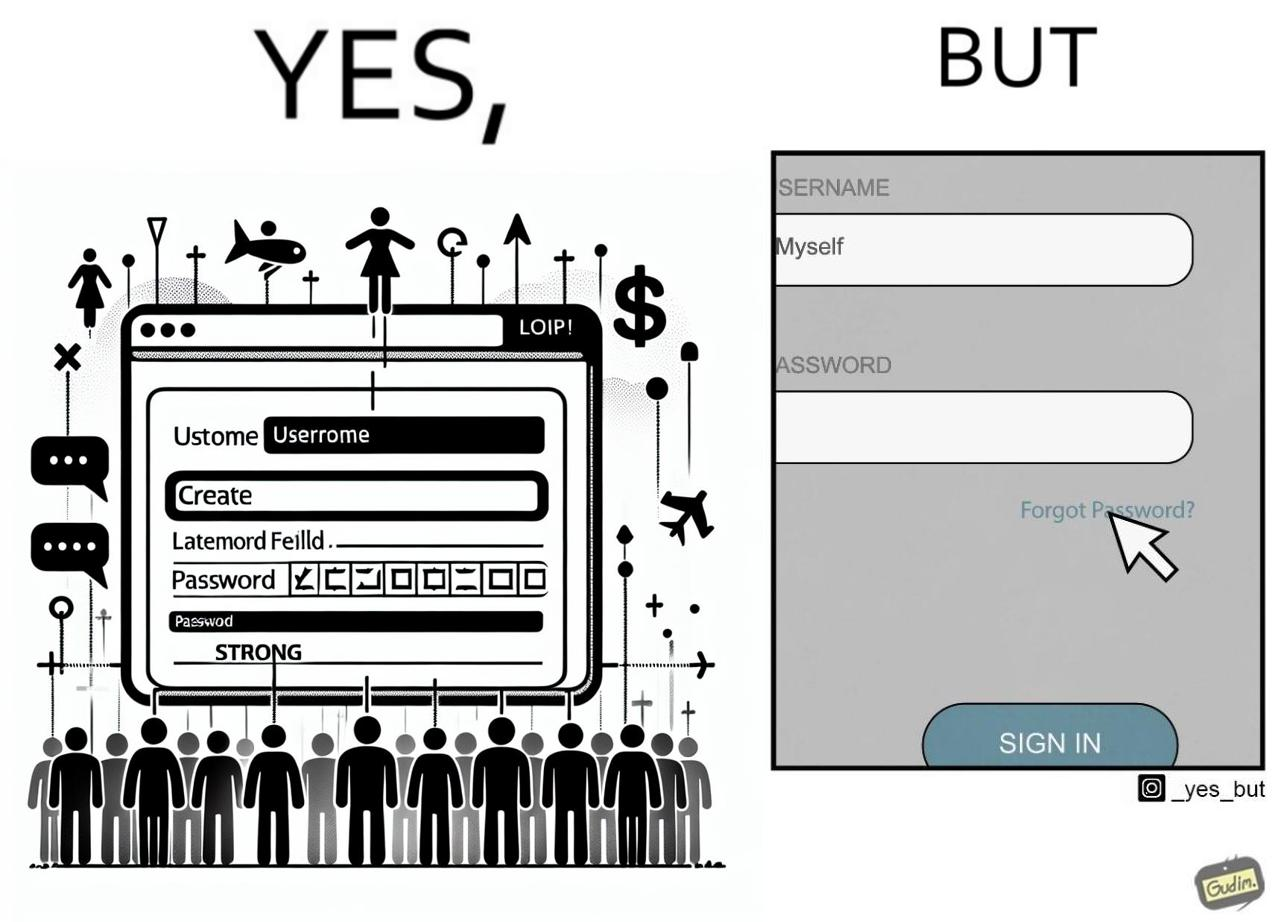Is this a satirical image? Yes, this image is satirical. 